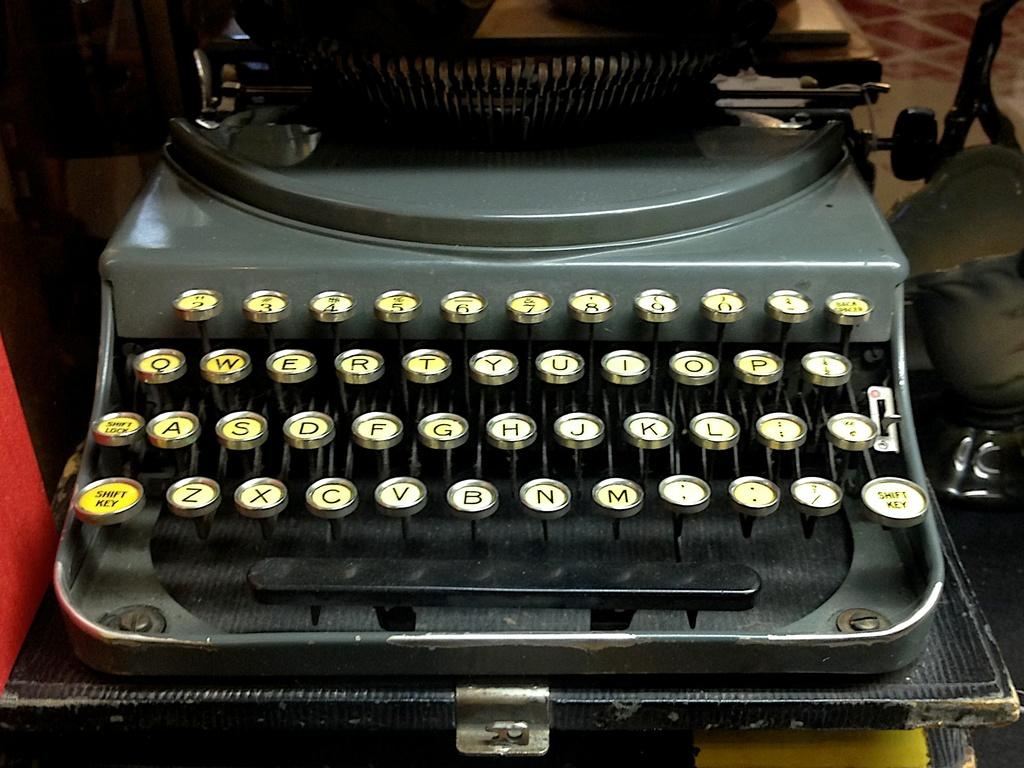<image>
Write a terse but informative summary of the picture. An old black typewriter with a qwerty keyboard. 